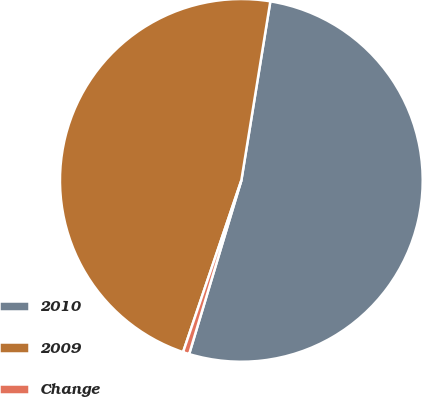Convert chart to OTSL. <chart><loc_0><loc_0><loc_500><loc_500><pie_chart><fcel>2010<fcel>2009<fcel>Change<nl><fcel>52.09%<fcel>47.35%<fcel>0.56%<nl></chart> 